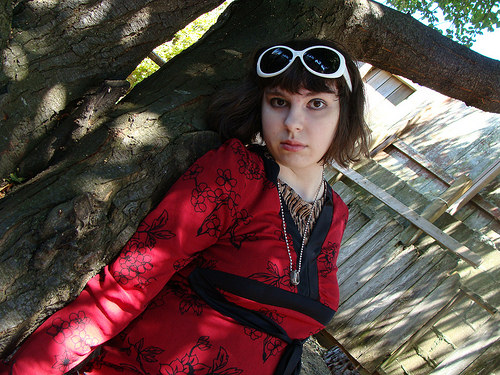<image>
Is there a women on the eyeglass? No. The women is not positioned on the eyeglass. They may be near each other, but the women is not supported by or resting on top of the eyeglass. 